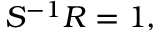<formula> <loc_0><loc_0><loc_500><loc_500>S ^ { - 1 } R = 1 ,</formula> 